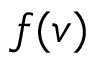Convert formula to latex. <formula><loc_0><loc_0><loc_500><loc_500>f ( v )</formula> 